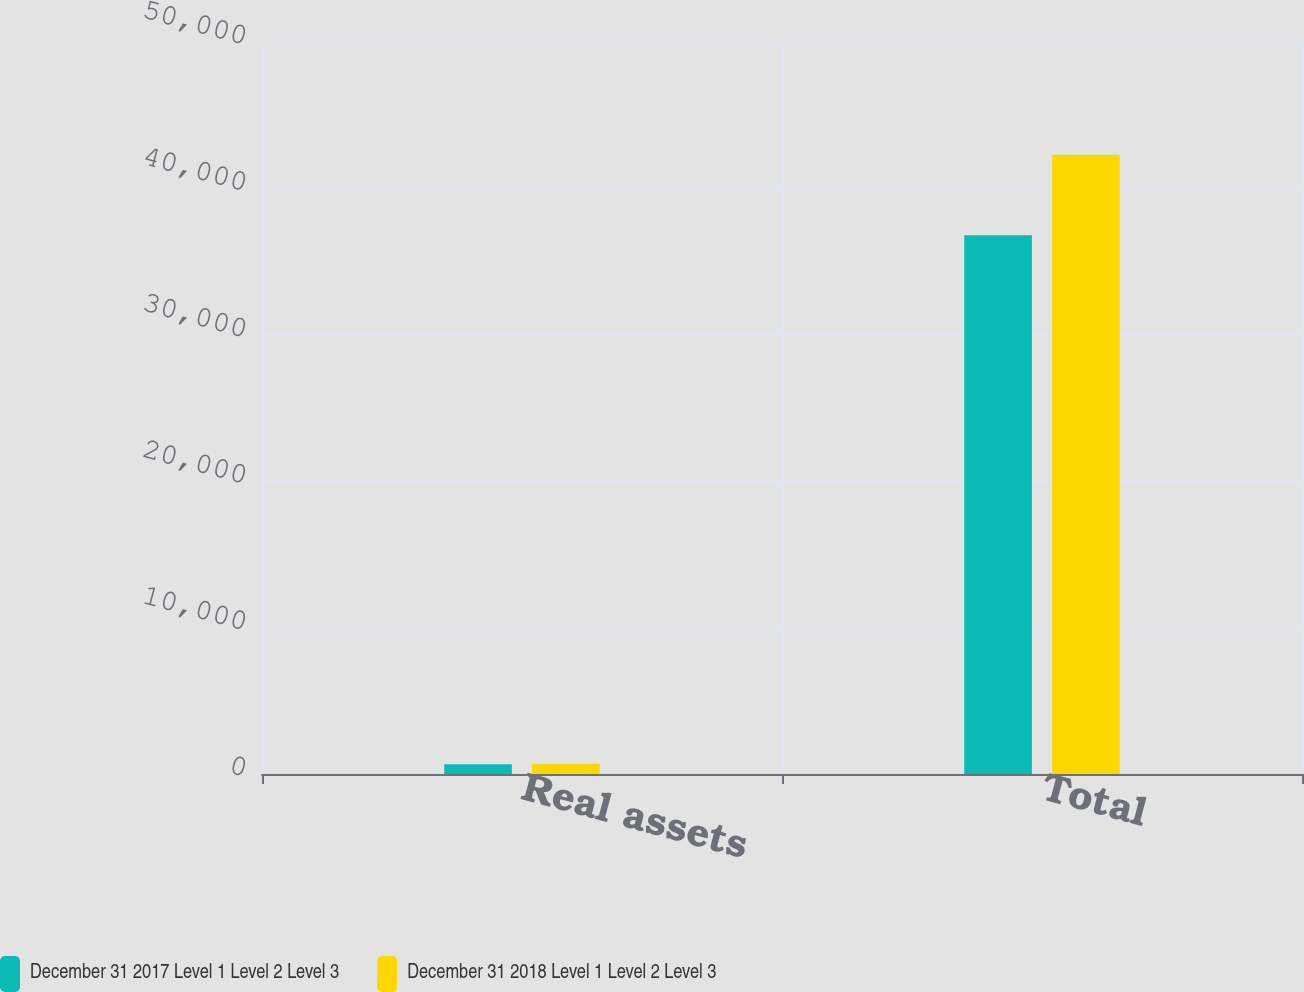<chart> <loc_0><loc_0><loc_500><loc_500><stacked_bar_chart><ecel><fcel>Real assets<fcel>Total<nl><fcel>December 31 2017 Level 1 Level 2 Level 3<fcel>659<fcel>36793<nl><fcel>December 31 2018 Level 1 Level 2 Level 3<fcel>705<fcel>42305<nl></chart> 